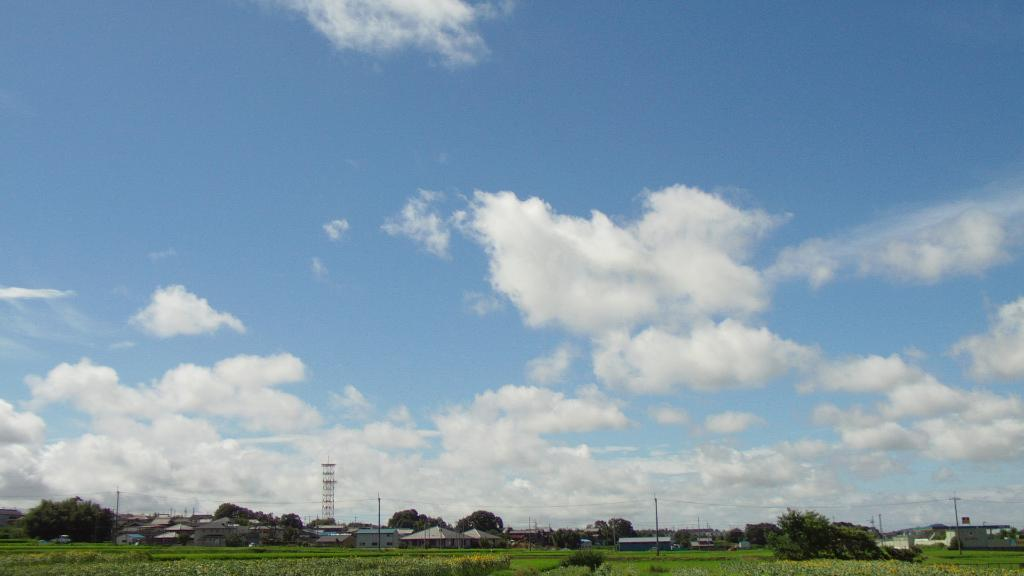What type of structures can be seen in the image? There are houses and a tower visible in the image. What are the poles in the image used for? The poles in the image are likely used to support the wires. What type of vegetation is present in the image? There is grass, plants, and trees visible in the image. What is visible in the sky in the image? The sky is visible in the image, and there are clouds present. Can you tell me where the river is located in the image? There is no river present in the image. What type of farm can be seen in the background of the image? There is no farm present in the image. 